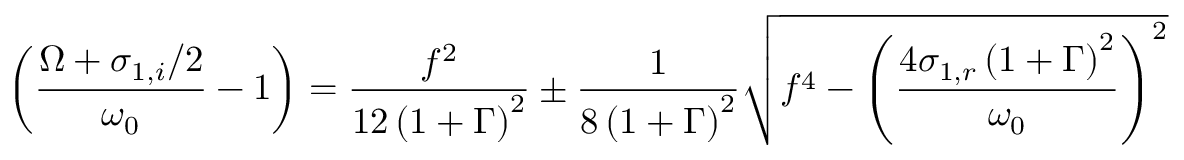<formula> <loc_0><loc_0><loc_500><loc_500>\left ( \frac { \Omega + \sigma _ { 1 , i } / 2 } { \omega _ { 0 } } - 1 \right ) = \frac { f ^ { 2 } } { 1 2 \left ( 1 + \Gamma \right ) ^ { 2 } } \pm \frac { 1 } { 8 \left ( 1 + \Gamma \right ) ^ { 2 } } \sqrt { f ^ { 4 } - \left ( \frac { 4 \sigma _ { 1 , r } \left ( 1 + \Gamma \right ) ^ { 2 } } { \omega _ { 0 } } \right ) ^ { 2 } }</formula> 